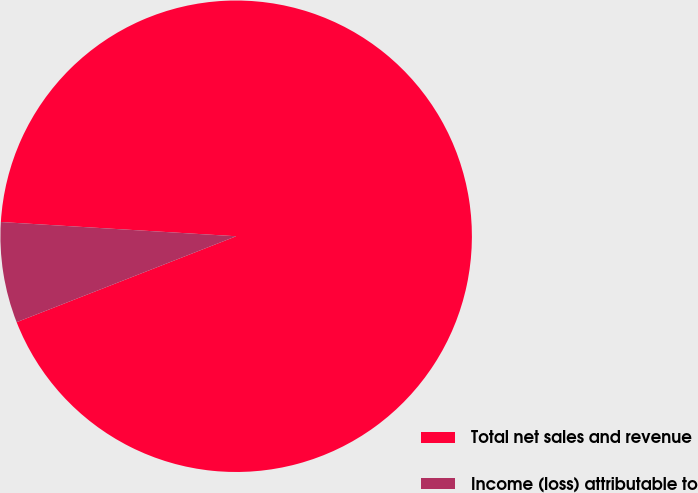Convert chart. <chart><loc_0><loc_0><loc_500><loc_500><pie_chart><fcel>Total net sales and revenue<fcel>Income (loss) attributable to<nl><fcel>93.1%<fcel>6.9%<nl></chart> 